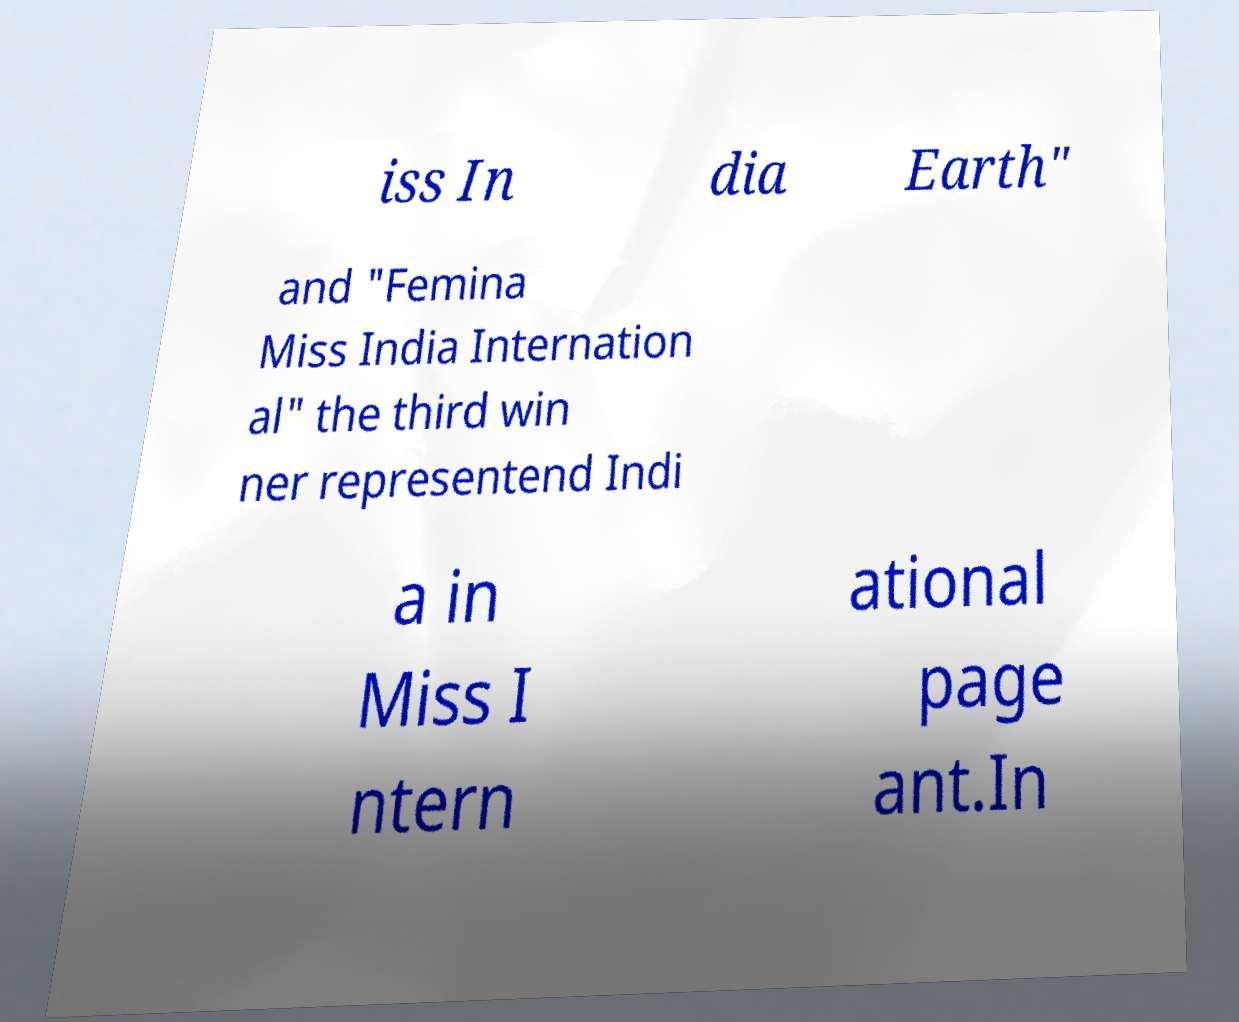Can you read and provide the text displayed in the image?This photo seems to have some interesting text. Can you extract and type it out for me? iss In dia Earth" and "Femina Miss India Internation al" the third win ner representend Indi a in Miss I ntern ational page ant.In 